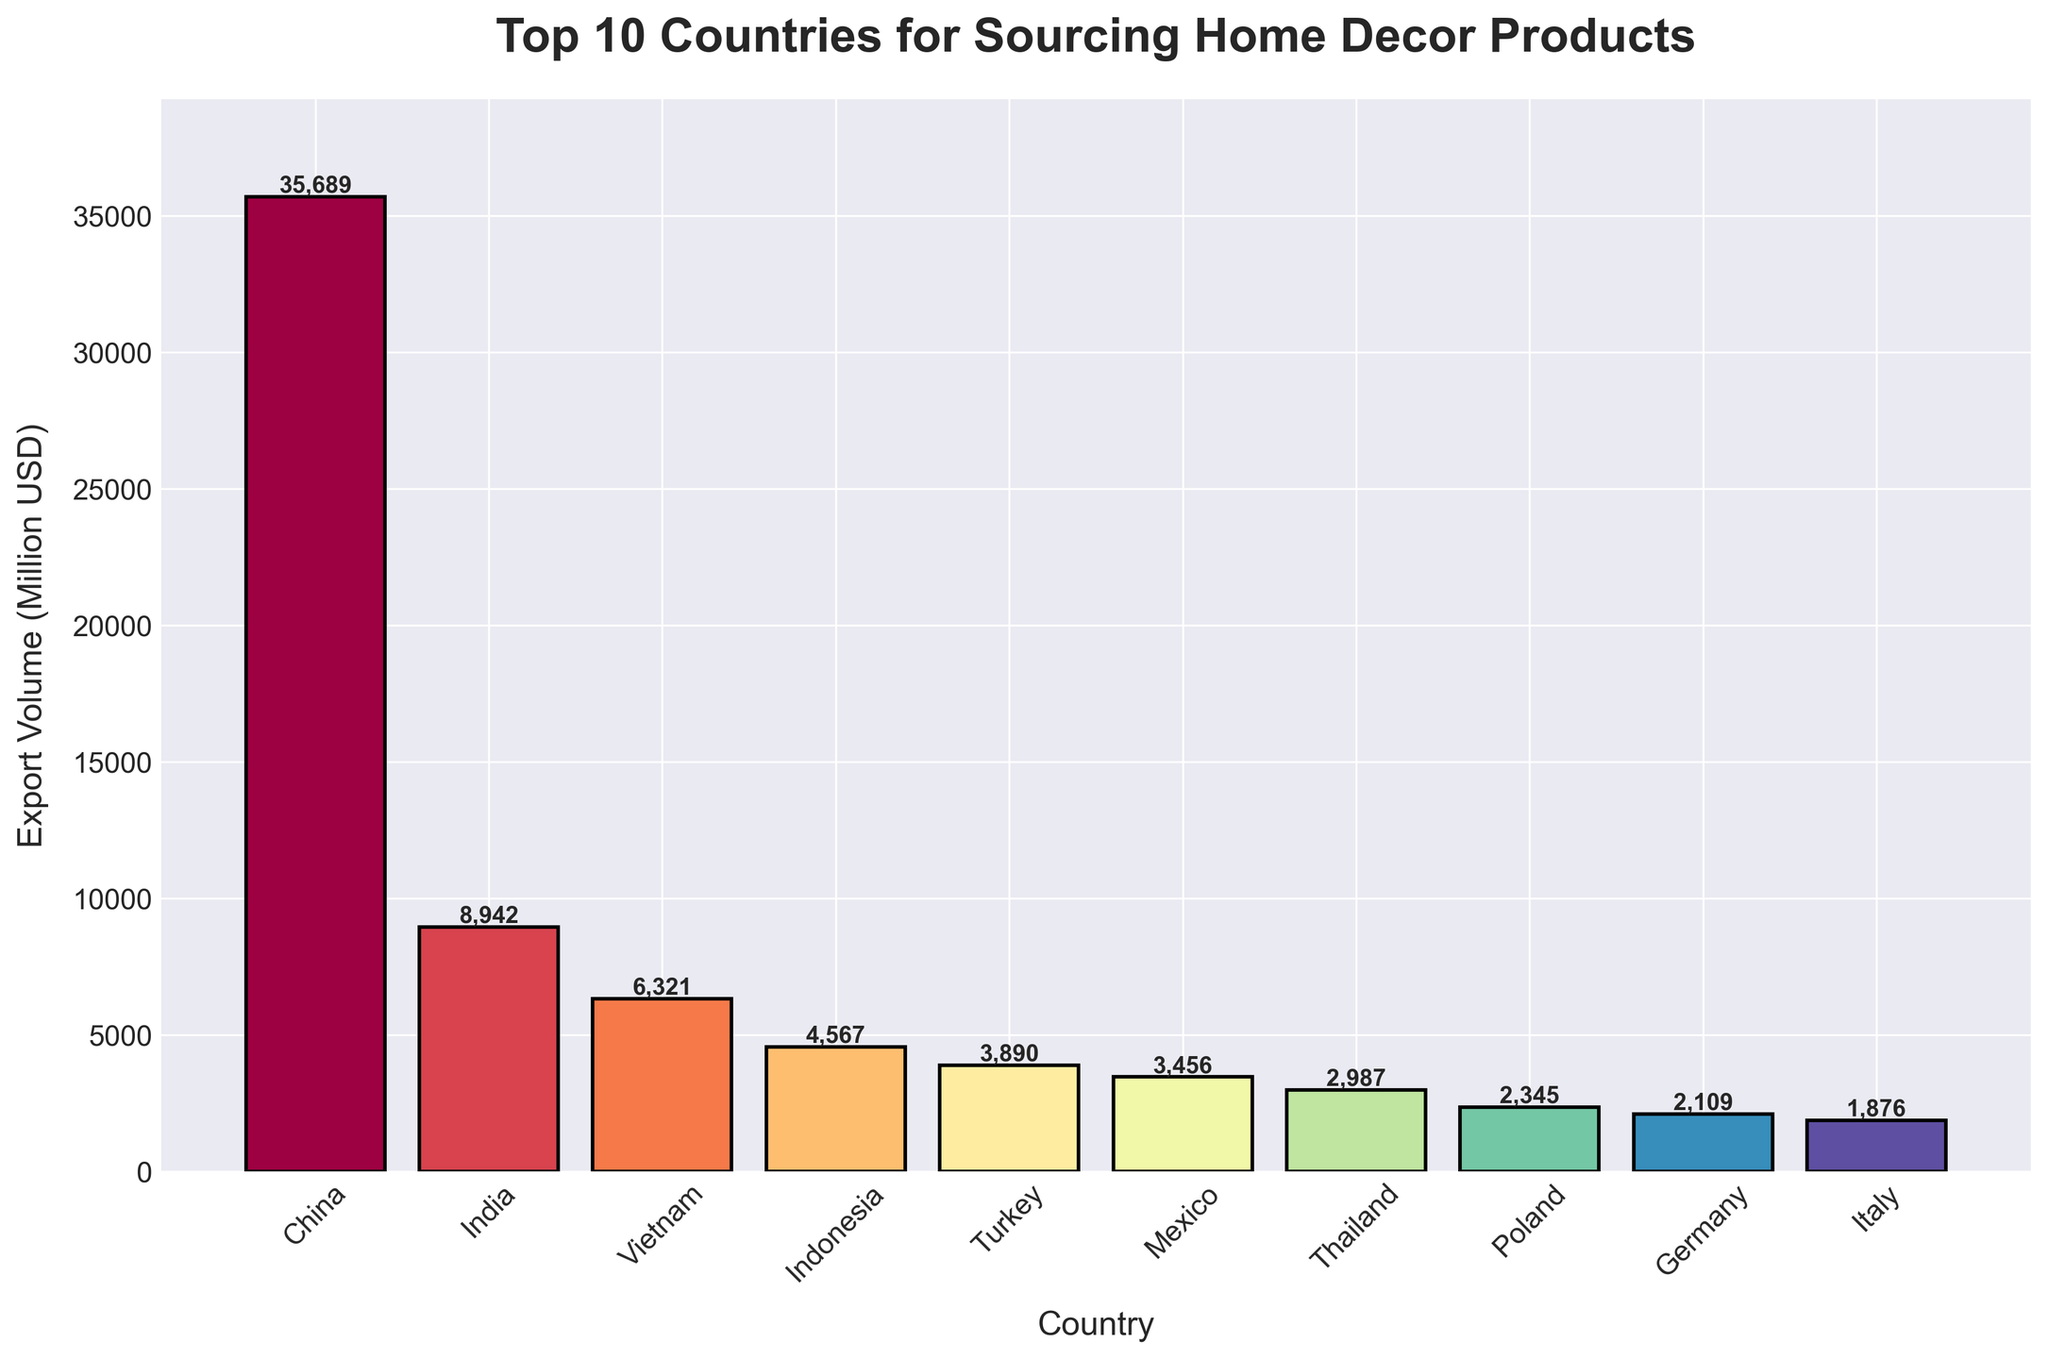How many countries have an export volume greater than 5,000 million USD? Look at the bar heights for each country. Countries with a bar height above 5,000 million USD are China, India, and Vietnam, totaling 3 countries.
Answer: 3 Which country has the lowest export volume? Look at the bar heights and find the shortest bar. The shortest bar corresponds to Italy.
Answer: Italy What is the sum of export volumes of Turkey, Mexico, and Thailand? Add the export volumes of Turkey (3,890), Mexico (3,456), and Thailand (2,987): 3,890 + 3,456 + 2,987 = 10,333 million USD.
Answer: 10,333 Is India's export volume more than double that of Germany's? India's export volume is 8,942 million USD and Germany's is 2,109 million USD. Double of Germany's is 2,109 * 2 = 4,218. Since 8,942 > 4,218, India's export volume is more than double that of Germany.
Answer: Yes Which country ranks second in terms of export volume? Arrange the countries by the height of their bars. The second tallest bar is that of India.
Answer: India What is the average export volume of the bottom four countries? The bottom four countries are Poland (2,345), Germany (2,109), Italy (1,876), and Thailand (2,987). Their total export volume is 2,345 + 2,109 + 1,876 + 2,987 = 9,317. The average is 9,317 / 4 = 2,329.25 million USD.
Answer: 2,329.25 How much more is China's export volume compared to Indonesia's? Subtract Indonesia's export volume (4,567) from China's (35,689): 35,689 - 4,567 = 31,122 million USD.
Answer: 31,122 What is the export volume difference between Indonesia and Thailand? Subtract Thailand's export volume (2,987) from Indonesia's (4,567): 4,567 - 2,987 = 1,580 million USD.
Answer: 1,580 